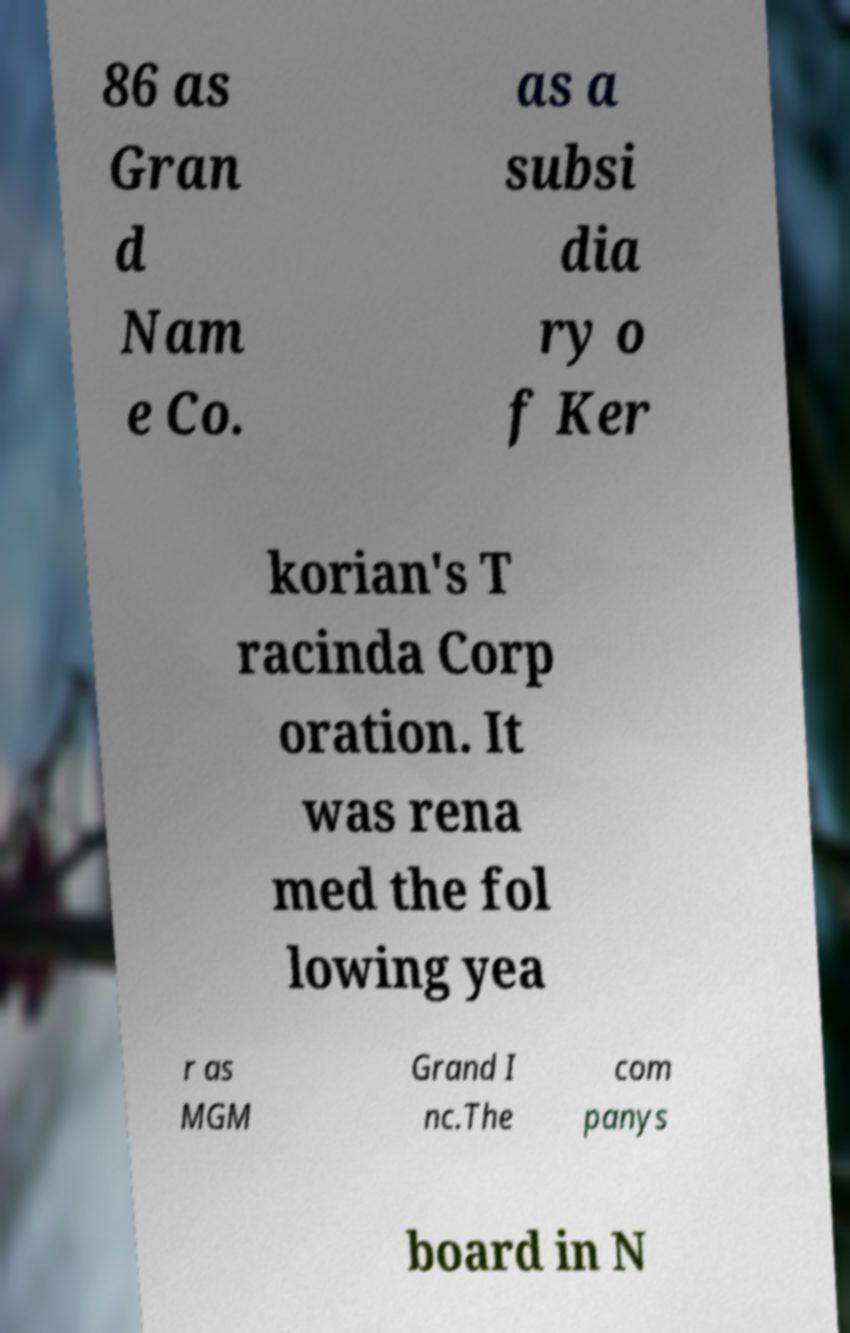Can you read and provide the text displayed in the image?This photo seems to have some interesting text. Can you extract and type it out for me? 86 as Gran d Nam e Co. as a subsi dia ry o f Ker korian's T racinda Corp oration. It was rena med the fol lowing yea r as MGM Grand I nc.The com panys board in N 